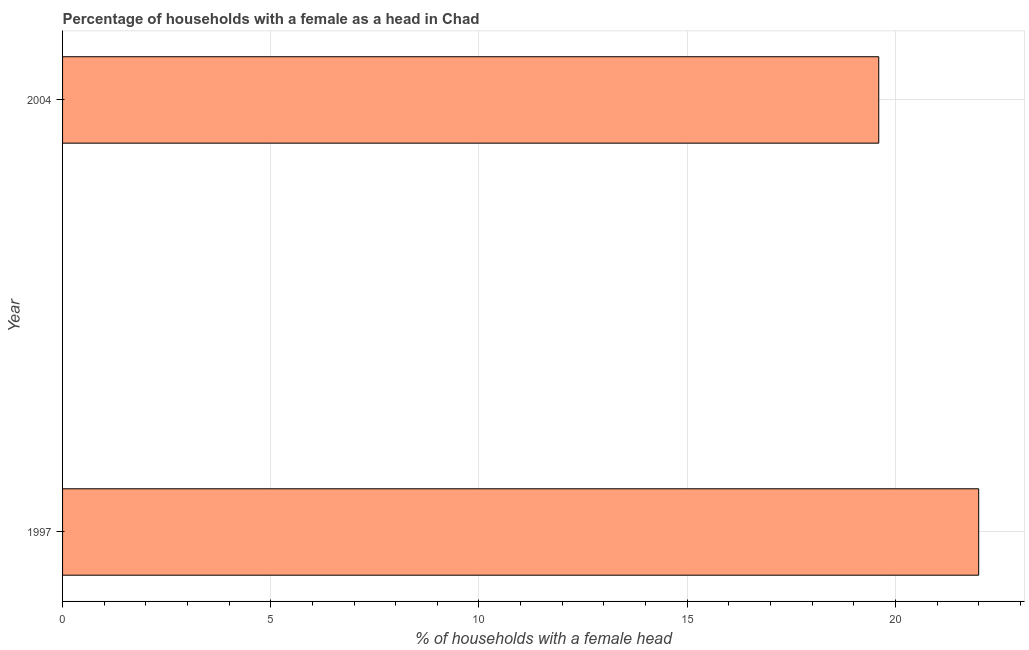Does the graph contain grids?
Provide a short and direct response. Yes. What is the title of the graph?
Provide a succinct answer. Percentage of households with a female as a head in Chad. What is the label or title of the X-axis?
Provide a short and direct response. % of households with a female head. What is the number of female supervised households in 1997?
Offer a terse response. 22. Across all years, what is the minimum number of female supervised households?
Provide a short and direct response. 19.6. In which year was the number of female supervised households maximum?
Give a very brief answer. 1997. What is the sum of the number of female supervised households?
Make the answer very short. 41.6. What is the average number of female supervised households per year?
Offer a very short reply. 20.8. What is the median number of female supervised households?
Provide a short and direct response. 20.8. What is the ratio of the number of female supervised households in 1997 to that in 2004?
Provide a short and direct response. 1.12. Is the number of female supervised households in 1997 less than that in 2004?
Ensure brevity in your answer.  No. How many bars are there?
Your response must be concise. 2. What is the difference between two consecutive major ticks on the X-axis?
Offer a terse response. 5. What is the % of households with a female head in 1997?
Offer a terse response. 22. What is the % of households with a female head of 2004?
Your response must be concise. 19.6. What is the ratio of the % of households with a female head in 1997 to that in 2004?
Offer a very short reply. 1.12. 